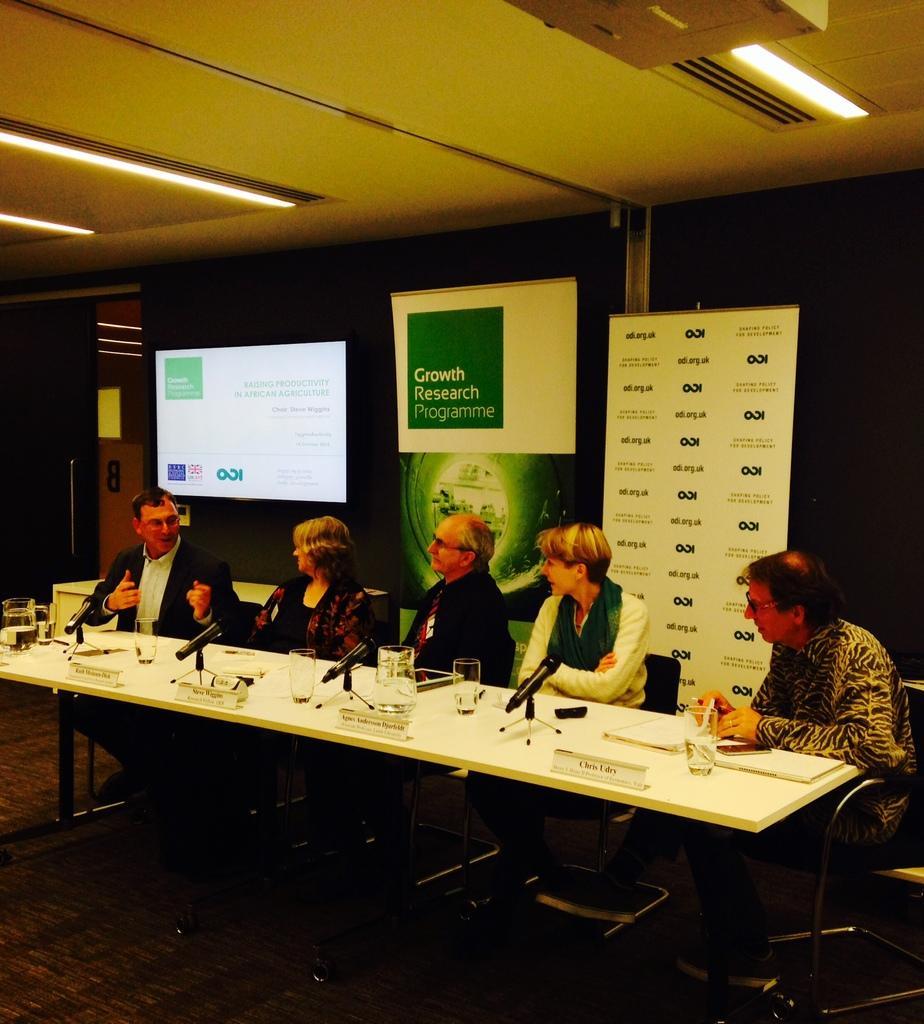Please provide a concise description of this image. In this image I can see few people are sitting on chairs, in the front of them I can see a white colour table and on it I can see number of glasses, few boards, few mice and on these boards I can see something is written. In the background I can see a projector's screen, few boards and on these boards I can see something is written. 